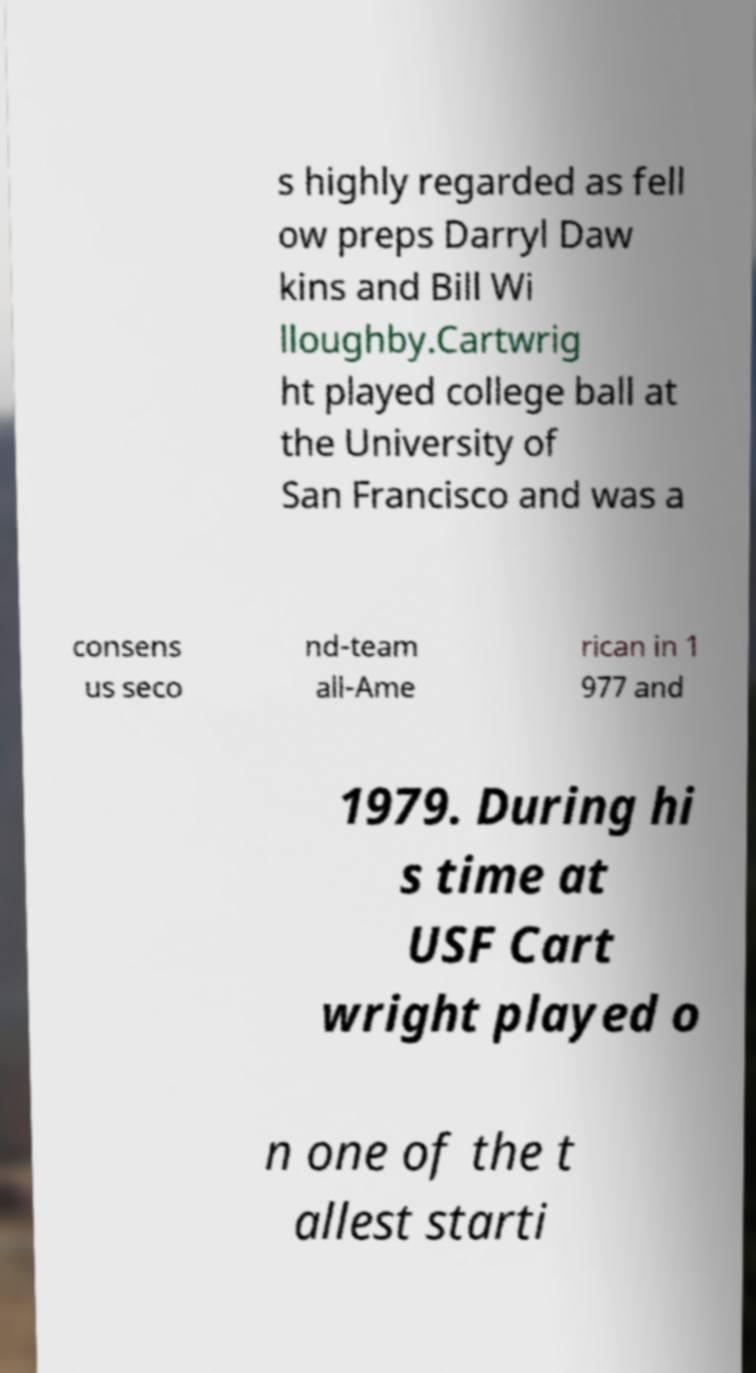There's text embedded in this image that I need extracted. Can you transcribe it verbatim? s highly regarded as fell ow preps Darryl Daw kins and Bill Wi lloughby.Cartwrig ht played college ball at the University of San Francisco and was a consens us seco nd-team all-Ame rican in 1 977 and 1979. During hi s time at USF Cart wright played o n one of the t allest starti 